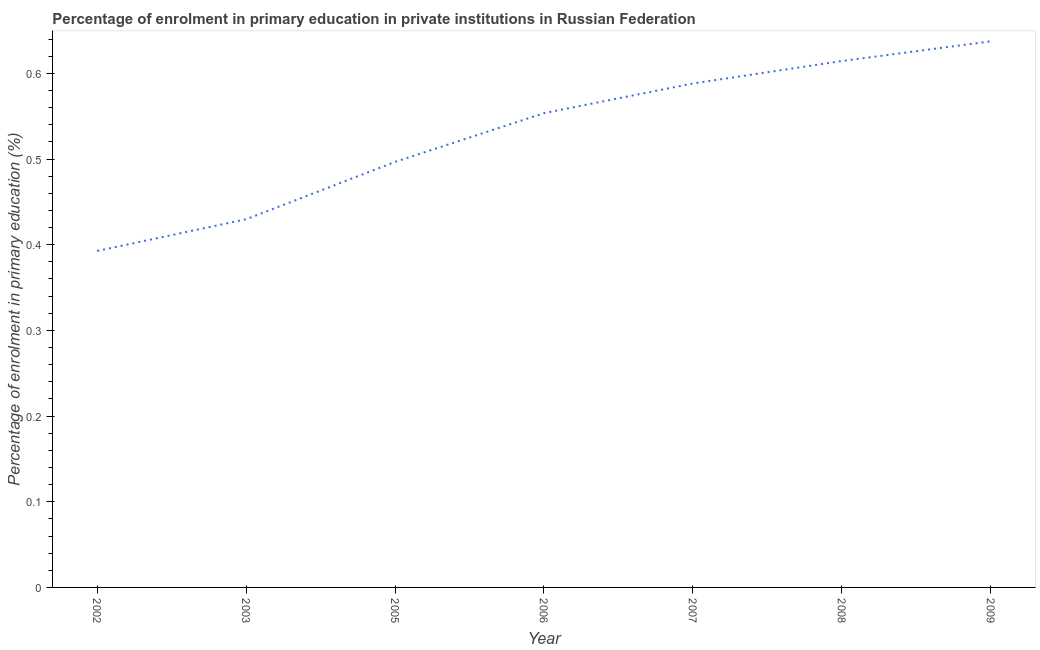What is the enrolment percentage in primary education in 2009?
Provide a succinct answer. 0.64. Across all years, what is the maximum enrolment percentage in primary education?
Keep it short and to the point. 0.64. Across all years, what is the minimum enrolment percentage in primary education?
Keep it short and to the point. 0.39. In which year was the enrolment percentage in primary education maximum?
Provide a succinct answer. 2009. What is the sum of the enrolment percentage in primary education?
Your response must be concise. 3.71. What is the difference between the enrolment percentage in primary education in 2006 and 2008?
Offer a very short reply. -0.06. What is the average enrolment percentage in primary education per year?
Give a very brief answer. 0.53. What is the median enrolment percentage in primary education?
Ensure brevity in your answer.  0.55. In how many years, is the enrolment percentage in primary education greater than 0.42000000000000004 %?
Give a very brief answer. 6. Do a majority of the years between 2005 and 2008 (inclusive) have enrolment percentage in primary education greater than 0.34 %?
Your response must be concise. Yes. What is the ratio of the enrolment percentage in primary education in 2008 to that in 2009?
Provide a short and direct response. 0.96. Is the difference between the enrolment percentage in primary education in 2002 and 2009 greater than the difference between any two years?
Keep it short and to the point. Yes. What is the difference between the highest and the second highest enrolment percentage in primary education?
Give a very brief answer. 0.02. Is the sum of the enrolment percentage in primary education in 2002 and 2009 greater than the maximum enrolment percentage in primary education across all years?
Offer a very short reply. Yes. What is the difference between the highest and the lowest enrolment percentage in primary education?
Your response must be concise. 0.24. In how many years, is the enrolment percentage in primary education greater than the average enrolment percentage in primary education taken over all years?
Ensure brevity in your answer.  4. What is the difference between two consecutive major ticks on the Y-axis?
Make the answer very short. 0.1. Does the graph contain any zero values?
Provide a succinct answer. No. What is the title of the graph?
Your answer should be compact. Percentage of enrolment in primary education in private institutions in Russian Federation. What is the label or title of the Y-axis?
Provide a short and direct response. Percentage of enrolment in primary education (%). What is the Percentage of enrolment in primary education (%) of 2002?
Offer a terse response. 0.39. What is the Percentage of enrolment in primary education (%) in 2003?
Your response must be concise. 0.43. What is the Percentage of enrolment in primary education (%) of 2005?
Your answer should be very brief. 0.5. What is the Percentage of enrolment in primary education (%) of 2006?
Your response must be concise. 0.55. What is the Percentage of enrolment in primary education (%) of 2007?
Offer a terse response. 0.59. What is the Percentage of enrolment in primary education (%) of 2008?
Make the answer very short. 0.61. What is the Percentage of enrolment in primary education (%) of 2009?
Give a very brief answer. 0.64. What is the difference between the Percentage of enrolment in primary education (%) in 2002 and 2003?
Make the answer very short. -0.04. What is the difference between the Percentage of enrolment in primary education (%) in 2002 and 2005?
Offer a terse response. -0.1. What is the difference between the Percentage of enrolment in primary education (%) in 2002 and 2006?
Give a very brief answer. -0.16. What is the difference between the Percentage of enrolment in primary education (%) in 2002 and 2007?
Offer a terse response. -0.2. What is the difference between the Percentage of enrolment in primary education (%) in 2002 and 2008?
Offer a very short reply. -0.22. What is the difference between the Percentage of enrolment in primary education (%) in 2002 and 2009?
Your answer should be very brief. -0.24. What is the difference between the Percentage of enrolment in primary education (%) in 2003 and 2005?
Your response must be concise. -0.07. What is the difference between the Percentage of enrolment in primary education (%) in 2003 and 2006?
Provide a short and direct response. -0.12. What is the difference between the Percentage of enrolment in primary education (%) in 2003 and 2007?
Keep it short and to the point. -0.16. What is the difference between the Percentage of enrolment in primary education (%) in 2003 and 2008?
Ensure brevity in your answer.  -0.18. What is the difference between the Percentage of enrolment in primary education (%) in 2003 and 2009?
Your answer should be very brief. -0.21. What is the difference between the Percentage of enrolment in primary education (%) in 2005 and 2006?
Your answer should be very brief. -0.06. What is the difference between the Percentage of enrolment in primary education (%) in 2005 and 2007?
Offer a very short reply. -0.09. What is the difference between the Percentage of enrolment in primary education (%) in 2005 and 2008?
Give a very brief answer. -0.12. What is the difference between the Percentage of enrolment in primary education (%) in 2005 and 2009?
Keep it short and to the point. -0.14. What is the difference between the Percentage of enrolment in primary education (%) in 2006 and 2007?
Keep it short and to the point. -0.03. What is the difference between the Percentage of enrolment in primary education (%) in 2006 and 2008?
Provide a succinct answer. -0.06. What is the difference between the Percentage of enrolment in primary education (%) in 2006 and 2009?
Provide a short and direct response. -0.08. What is the difference between the Percentage of enrolment in primary education (%) in 2007 and 2008?
Give a very brief answer. -0.03. What is the difference between the Percentage of enrolment in primary education (%) in 2007 and 2009?
Offer a terse response. -0.05. What is the difference between the Percentage of enrolment in primary education (%) in 2008 and 2009?
Provide a succinct answer. -0.02. What is the ratio of the Percentage of enrolment in primary education (%) in 2002 to that in 2003?
Provide a succinct answer. 0.91. What is the ratio of the Percentage of enrolment in primary education (%) in 2002 to that in 2005?
Offer a very short reply. 0.79. What is the ratio of the Percentage of enrolment in primary education (%) in 2002 to that in 2006?
Ensure brevity in your answer.  0.71. What is the ratio of the Percentage of enrolment in primary education (%) in 2002 to that in 2007?
Ensure brevity in your answer.  0.67. What is the ratio of the Percentage of enrolment in primary education (%) in 2002 to that in 2008?
Provide a short and direct response. 0.64. What is the ratio of the Percentage of enrolment in primary education (%) in 2002 to that in 2009?
Your response must be concise. 0.62. What is the ratio of the Percentage of enrolment in primary education (%) in 2003 to that in 2005?
Provide a short and direct response. 0.86. What is the ratio of the Percentage of enrolment in primary education (%) in 2003 to that in 2006?
Make the answer very short. 0.78. What is the ratio of the Percentage of enrolment in primary education (%) in 2003 to that in 2007?
Provide a succinct answer. 0.73. What is the ratio of the Percentage of enrolment in primary education (%) in 2003 to that in 2008?
Offer a terse response. 0.7. What is the ratio of the Percentage of enrolment in primary education (%) in 2003 to that in 2009?
Provide a short and direct response. 0.67. What is the ratio of the Percentage of enrolment in primary education (%) in 2005 to that in 2006?
Ensure brevity in your answer.  0.9. What is the ratio of the Percentage of enrolment in primary education (%) in 2005 to that in 2007?
Offer a very short reply. 0.84. What is the ratio of the Percentage of enrolment in primary education (%) in 2005 to that in 2008?
Ensure brevity in your answer.  0.81. What is the ratio of the Percentage of enrolment in primary education (%) in 2005 to that in 2009?
Provide a short and direct response. 0.78. What is the ratio of the Percentage of enrolment in primary education (%) in 2006 to that in 2007?
Ensure brevity in your answer.  0.94. What is the ratio of the Percentage of enrolment in primary education (%) in 2006 to that in 2008?
Your answer should be very brief. 0.9. What is the ratio of the Percentage of enrolment in primary education (%) in 2006 to that in 2009?
Offer a very short reply. 0.87. What is the ratio of the Percentage of enrolment in primary education (%) in 2007 to that in 2008?
Your response must be concise. 0.96. What is the ratio of the Percentage of enrolment in primary education (%) in 2007 to that in 2009?
Your response must be concise. 0.92. 